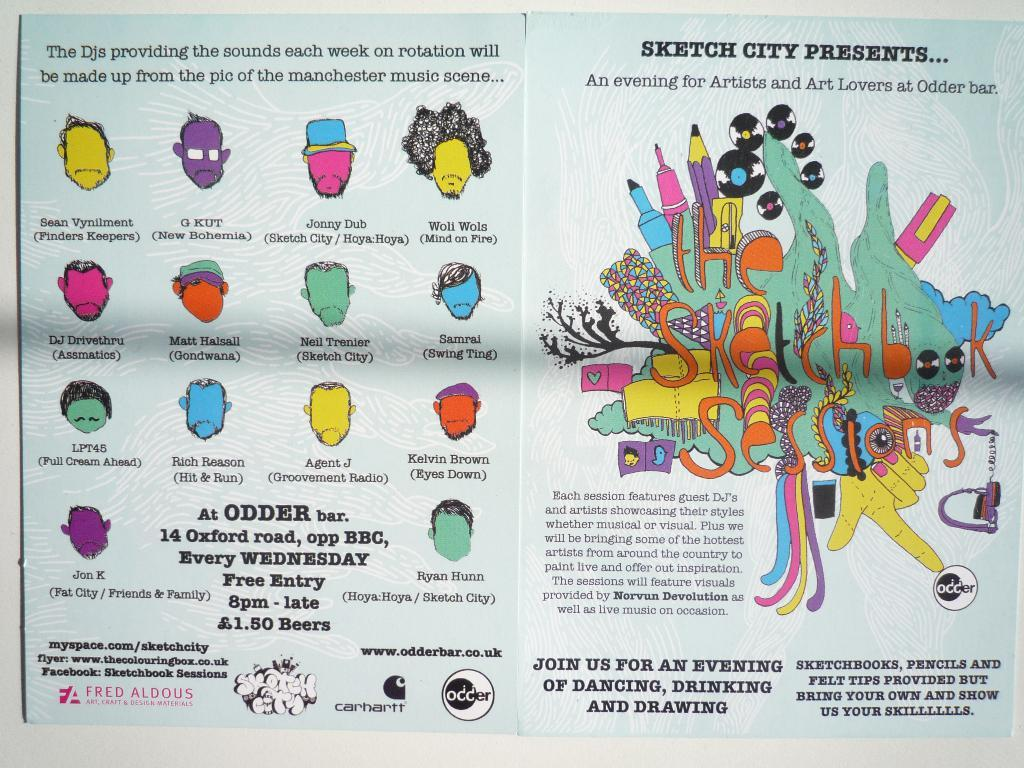Provide a one-sentence caption for the provided image. Odder Bar hosts a free art night every Wednesday. 